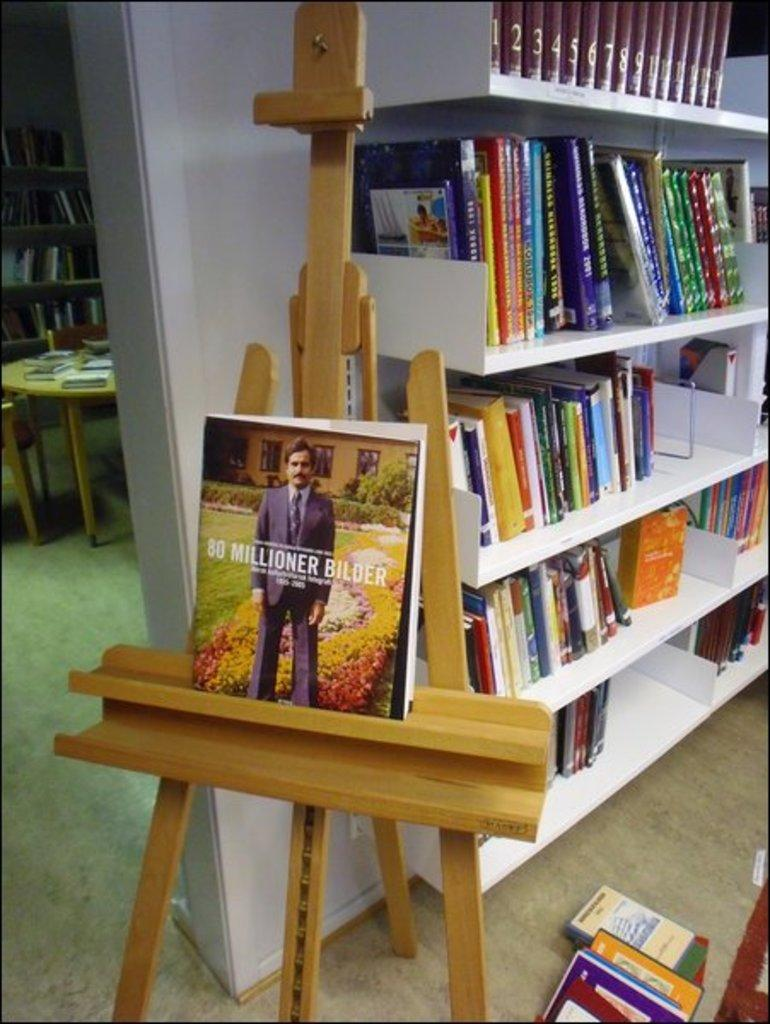What is on the rack in the image? The rack is filled with books. Are there any books located elsewhere in the image? Yes, there are books on the floor. What furniture is present in the image? There is a table and chairs in the image. What is on the table in the image? There are books on the table. What type of drain is visible in the image? There is no drain present in the image. What is the profit margin of the books on the table? There is no information about the profit margin of the books in the image. 